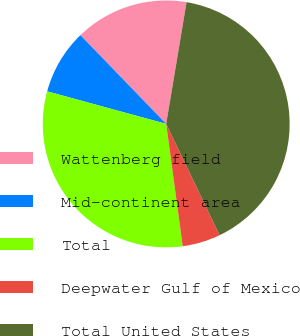Convert chart to OTSL. <chart><loc_0><loc_0><loc_500><loc_500><pie_chart><fcel>Wattenberg field<fcel>Mid-continent area<fcel>Total<fcel>Deepwater Gulf of Mexico<fcel>Total United States<nl><fcel>14.87%<fcel>8.52%<fcel>31.38%<fcel>4.99%<fcel>40.24%<nl></chart> 